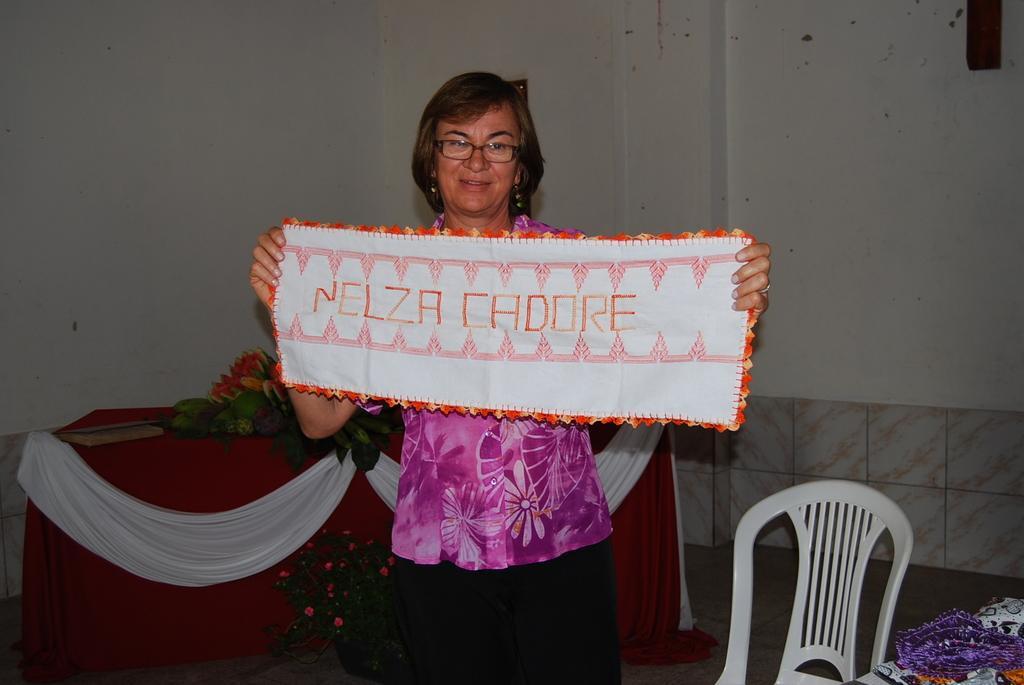Could you give a brief overview of what you see in this image? This is an inside view of a room. Here I can see a woman standing, holding a cloth in the hands, smiling and giving pose for the picture. Beside her there is a chair. In the background there is a table which is covered with a cloth. On the table there are some fruits and a book. At the back of this woman there is a flower pot which is placed on the floor. In the background there is a wall. 